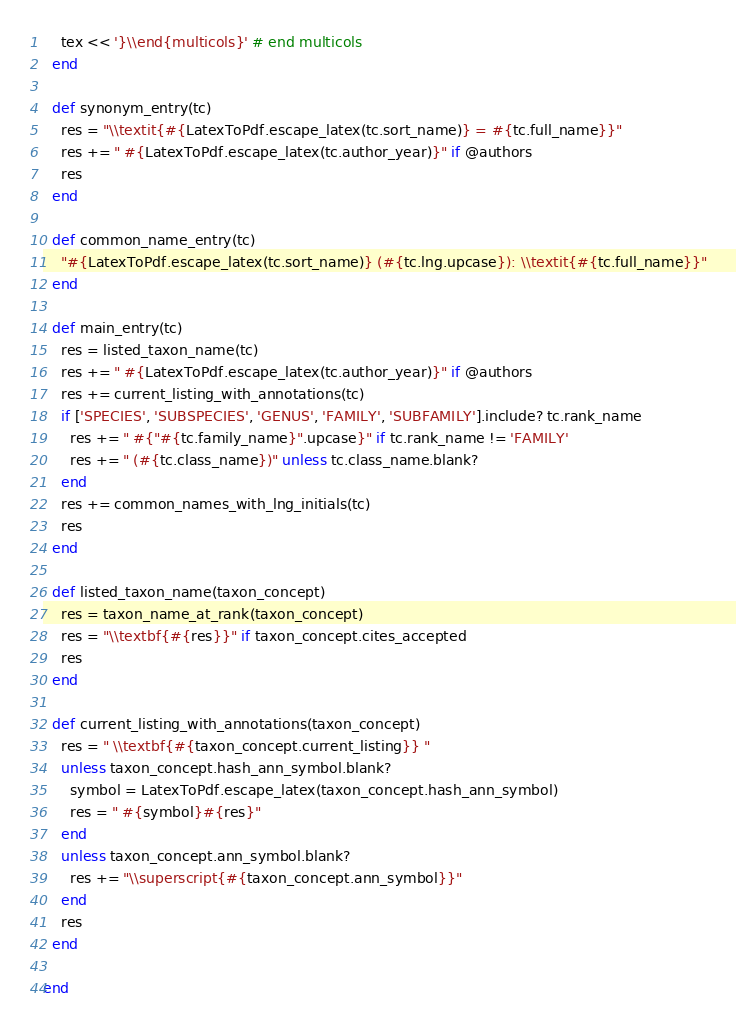Convert code to text. <code><loc_0><loc_0><loc_500><loc_500><_Ruby_>    tex << '}\\end{multicols}' # end multicols
  end

  def synonym_entry(tc)
    res = "\\textit{#{LatexToPdf.escape_latex(tc.sort_name)} = #{tc.full_name}}"
    res += " #{LatexToPdf.escape_latex(tc.author_year)}" if @authors
    res
  end

  def common_name_entry(tc)
    "#{LatexToPdf.escape_latex(tc.sort_name)} (#{tc.lng.upcase}): \\textit{#{tc.full_name}}"
  end

  def main_entry(tc)
    res = listed_taxon_name(tc)
    res += " #{LatexToPdf.escape_latex(tc.author_year)}" if @authors
    res += current_listing_with_annotations(tc)
    if ['SPECIES', 'SUBSPECIES', 'GENUS', 'FAMILY', 'SUBFAMILY'].include? tc.rank_name
      res += " #{"#{tc.family_name}".upcase}" if tc.rank_name != 'FAMILY'
      res += " (#{tc.class_name})" unless tc.class_name.blank?
    end
    res += common_names_with_lng_initials(tc)
    res
  end

  def listed_taxon_name(taxon_concept)
    res = taxon_name_at_rank(taxon_concept)
    res = "\\textbf{#{res}}" if taxon_concept.cites_accepted
    res
  end

  def current_listing_with_annotations(taxon_concept)
    res = " \\textbf{#{taxon_concept.current_listing}} "
    unless taxon_concept.hash_ann_symbol.blank?
      symbol = LatexToPdf.escape_latex(taxon_concept.hash_ann_symbol)
      res = " #{symbol}#{res}"
    end
    unless taxon_concept.ann_symbol.blank?
      res += "\\superscript{#{taxon_concept.ann_symbol}}"
    end
    res
  end

end
</code> 